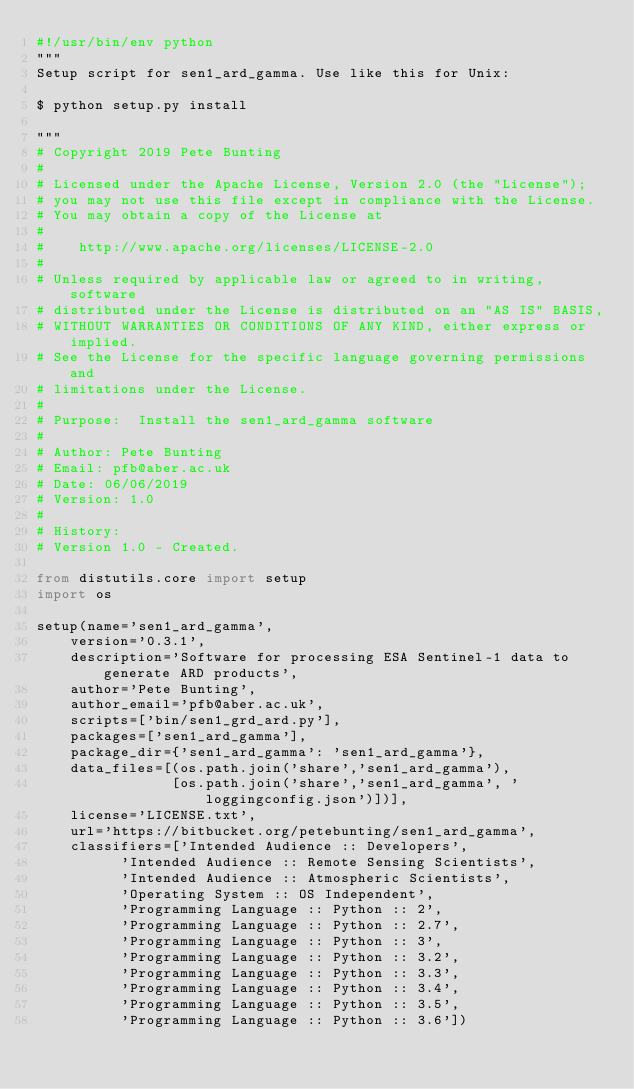Convert code to text. <code><loc_0><loc_0><loc_500><loc_500><_Python_>#!/usr/bin/env python
"""
Setup script for sen1_ard_gamma. Use like this for Unix:

$ python setup.py install

"""
# Copyright 2019 Pete Bunting
#
# Licensed under the Apache License, Version 2.0 (the "License");
# you may not use this file except in compliance with the License.
# You may obtain a copy of the License at
#
#    http://www.apache.org/licenses/LICENSE-2.0
#
# Unless required by applicable law or agreed to in writing, software
# distributed under the License is distributed on an "AS IS" BASIS,
# WITHOUT WARRANTIES OR CONDITIONS OF ANY KIND, either express or implied.
# See the License for the specific language governing permissions and
# limitations under the License.
#
# Purpose:  Install the sen1_ard_gamma software
#
# Author: Pete Bunting
# Email: pfb@aber.ac.uk
# Date: 06/06/2019
# Version: 1.0
#
# History:
# Version 1.0 - Created.

from distutils.core import setup
import os

setup(name='sen1_ard_gamma',
    version='0.3.1',
    description='Software for processing ESA Sentinel-1 data to generate ARD products',
    author='Pete Bunting',
    author_email='pfb@aber.ac.uk',
    scripts=['bin/sen1_grd_ard.py'],
    packages=['sen1_ard_gamma'],
    package_dir={'sen1_ard_gamma': 'sen1_ard_gamma'},
    data_files=[(os.path.join('share','sen1_ard_gamma'),
                [os.path.join('share','sen1_ard_gamma', 'loggingconfig.json')])],
    license='LICENSE.txt',
    url='https://bitbucket.org/petebunting/sen1_ard_gamma',
    classifiers=['Intended Audience :: Developers',
    	  'Intended Audience :: Remote Sensing Scientists',
    	  'Intended Audience :: Atmospheric Scientists',
          'Operating System :: OS Independent',
          'Programming Language :: Python :: 2',
          'Programming Language :: Python :: 2.7',
          'Programming Language :: Python :: 3',
          'Programming Language :: Python :: 3.2',
          'Programming Language :: Python :: 3.3',
          'Programming Language :: Python :: 3.4',
          'Programming Language :: Python :: 3.5',
          'Programming Language :: Python :: 3.6'])
</code> 